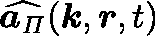Convert formula to latex. <formula><loc_0><loc_0><loc_500><loc_500>\widehat { a _ { \Pi } } ( k , r , t )</formula> 